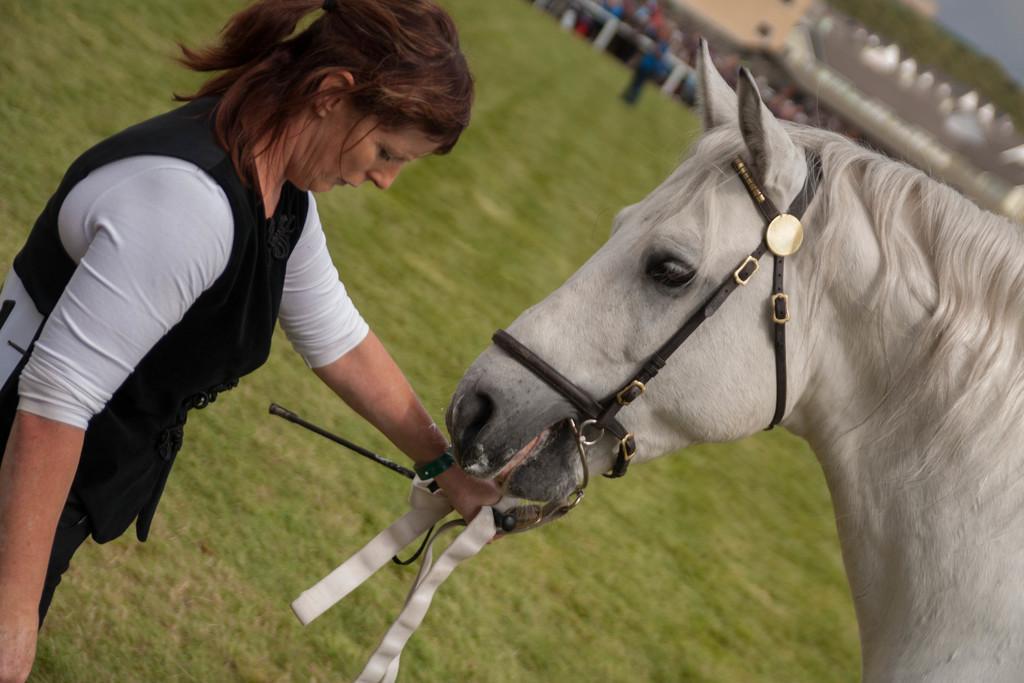Could you give a brief overview of what you see in this image? This is the picture of a place where we have a lady who is holding the horse and behind there are some trees, people and fencing. 